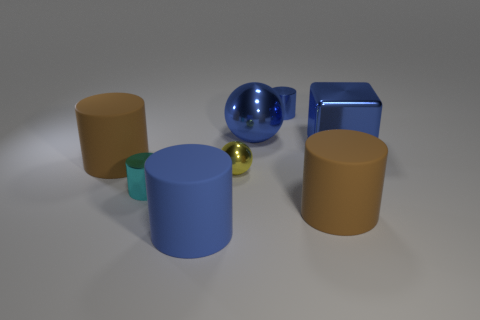There is a ball behind the blue metallic cube; does it have the same color as the tiny thing right of the tiny ball?
Provide a succinct answer. Yes. The blue object that is the same size as the cyan metal cylinder is what shape?
Your answer should be very brief. Cylinder. How many shiny objects are either tiny cubes or large brown cylinders?
Provide a succinct answer. 0. Is the number of cubes left of the large blue matte cylinder the same as the number of small yellow rubber cylinders?
Provide a short and direct response. Yes. There is a small cylinder on the right side of the tiny cyan shiny cylinder; does it have the same color as the large sphere?
Provide a succinct answer. Yes. There is a cylinder that is in front of the blue block and behind the cyan shiny cylinder; what is it made of?
Provide a short and direct response. Rubber. Is there a large blue thing to the right of the big brown matte cylinder that is to the right of the small yellow ball?
Provide a short and direct response. Yes. Are the large block and the big blue cylinder made of the same material?
Provide a short and direct response. No. What shape is the large thing that is left of the tiny blue cylinder and to the right of the tiny metallic sphere?
Keep it short and to the point. Sphere. There is a metal cylinder that is on the left side of the blue rubber object to the right of the tiny cyan object; how big is it?
Make the answer very short. Small. 